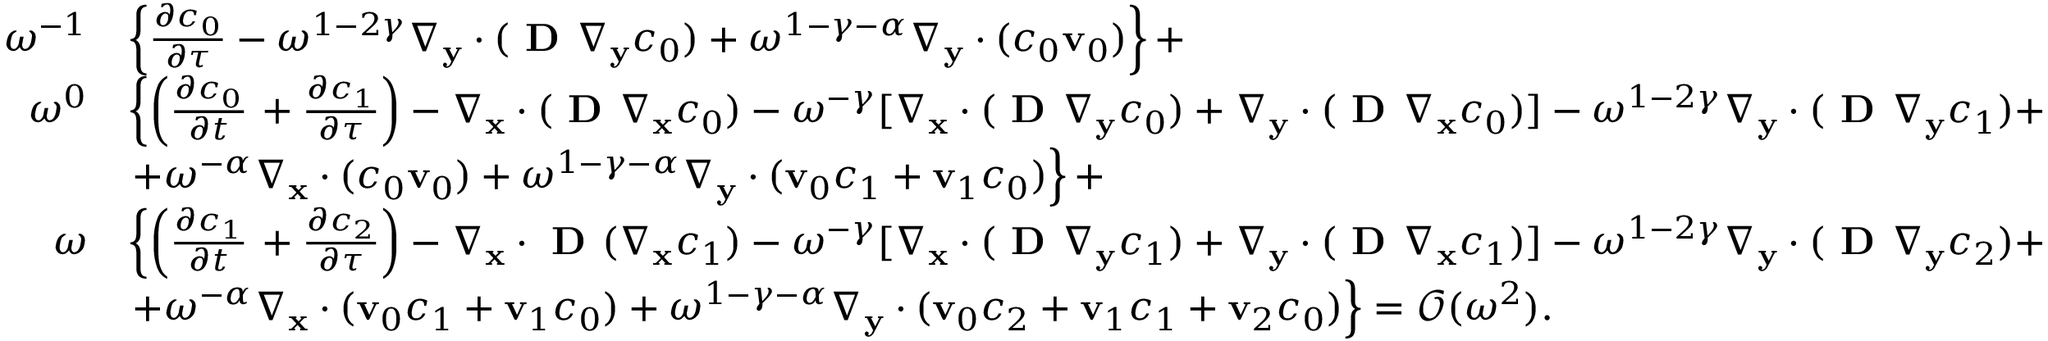<formula> <loc_0><loc_0><loc_500><loc_500>\begin{array} { r l } { \omega ^ { - 1 } } & { \left \{ \frac { \partial c _ { 0 } } { \partial \tau } - \omega ^ { 1 - 2 \gamma } \nabla _ { \mathbf y } \cdot ( D \nabla _ { \mathbf y } c _ { 0 } ) + \omega ^ { 1 - \gamma - \alpha } \nabla _ { \mathbf y } \cdot ( c _ { 0 } \mathbf v _ { 0 } ) \right \} + } \\ { \omega ^ { 0 } } & { \left \{ \left ( \frac { \partial c _ { 0 } } { \partial t } + \frac { \partial c _ { 1 } } { \partial \tau } \right ) - \nabla _ { \mathbf x } \cdot ( D \nabla _ { \mathbf x } c _ { 0 } ) - \omega ^ { - \gamma } [ \nabla _ { \mathbf x } \cdot ( D \nabla _ { \mathbf y } c _ { 0 } ) + \nabla _ { \mathbf y } \cdot ( D \nabla _ { \mathbf x } c _ { 0 } ) ] - \omega ^ { 1 - 2 \gamma } \nabla _ { \mathbf y } \cdot ( D \nabla _ { \mathbf y } c _ { 1 } ) + } \\ & { + \omega ^ { - \alpha } \nabla _ { \mathbf x } \cdot ( c _ { 0 } \mathbf v _ { 0 } ) + \omega ^ { 1 - \gamma - \alpha } \nabla _ { \mathbf y } \cdot ( \mathbf v _ { 0 } c _ { 1 } + \mathbf v _ { 1 } c _ { 0 } ) \right \} + } \\ { \omega } & { \left \{ \left ( \frac { \partial c _ { 1 } } { \partial t } + \frac { \partial c _ { 2 } } { \partial \tau } \right ) - \nabla _ { \mathbf x } \cdot D ( \nabla _ { \mathbf x } c _ { 1 } ) - \omega ^ { - \gamma } [ \nabla _ { \mathbf x } \cdot ( D \nabla _ { \mathbf y } c _ { 1 } ) + \nabla _ { \mathbf y } \cdot ( D \nabla _ { \mathbf x } c _ { 1 } ) ] - \omega ^ { 1 - 2 \gamma } \nabla _ { \mathbf y } \cdot ( D \nabla _ { \mathbf y } c _ { 2 } ) + } \\ & { + \omega ^ { - \alpha } \nabla _ { \mathbf x } \cdot ( \mathbf v _ { 0 } c _ { 1 } + \mathbf v _ { 1 } c _ { 0 } ) + \omega ^ { 1 - \gamma - \alpha } \nabla _ { \mathbf y } \cdot ( \mathbf v _ { 0 } c _ { 2 } + \mathbf v _ { 1 } c _ { 1 } + \mathbf v _ { 2 } c _ { 0 } ) \right \} = \mathcal { O } ( \omega ^ { 2 } ) . } \end{array}</formula> 